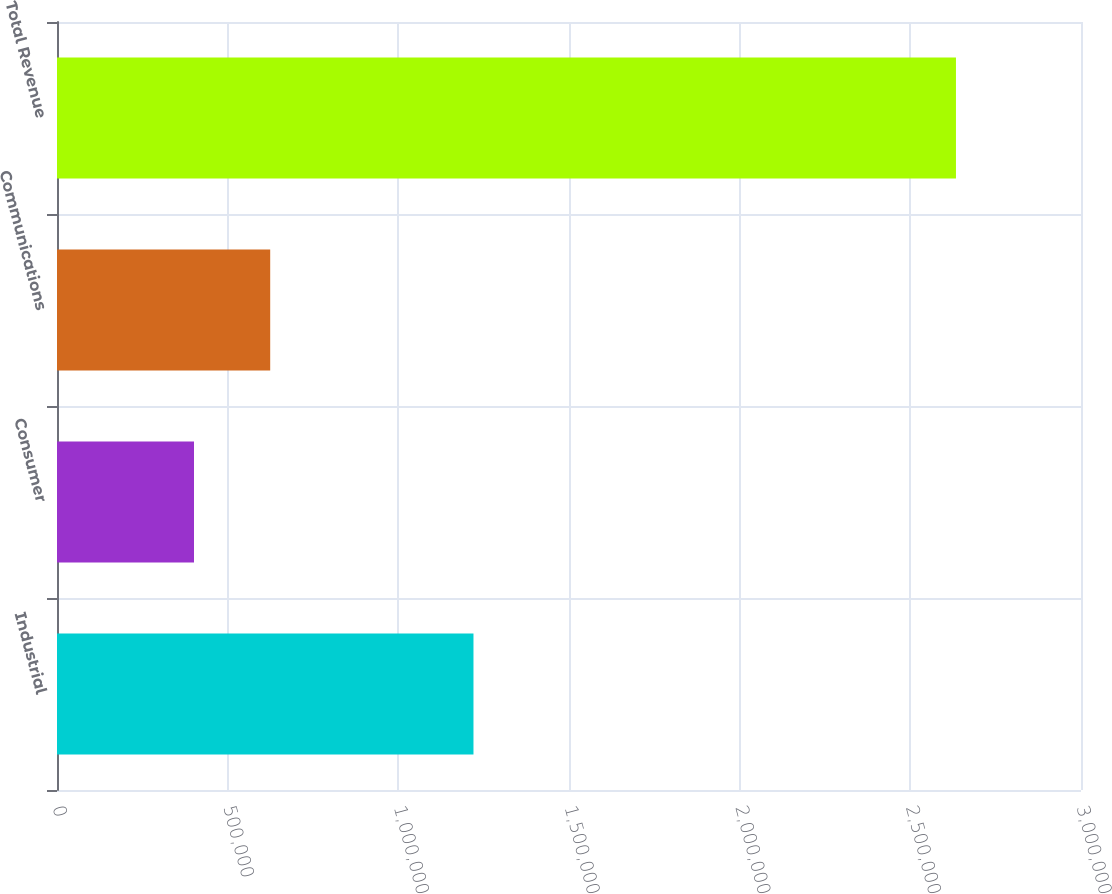Convert chart. <chart><loc_0><loc_0><loc_500><loc_500><bar_chart><fcel>Industrial<fcel>Consumer<fcel>Communications<fcel>Total Revenue<nl><fcel>1.22014e+06<fcel>401368<fcel>624600<fcel>2.63369e+06<nl></chart> 